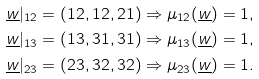<formula> <loc_0><loc_0><loc_500><loc_500>\underline { w } | _ { 1 2 } = ( 1 2 , 1 2 , 2 1 ) & \Rightarrow \mu _ { 1 2 } ( \underline { w } ) = 1 , \\ \underline { w } | _ { 1 3 } = ( 1 3 , 3 1 , 3 1 ) & \Rightarrow \mu _ { 1 3 } ( \underline { w } ) = 1 , \\ \underline { w } | _ { 2 3 } = ( 2 3 , 3 2 , 3 2 ) & \Rightarrow \mu _ { 2 3 } ( \underline { w } ) = 1 .</formula> 